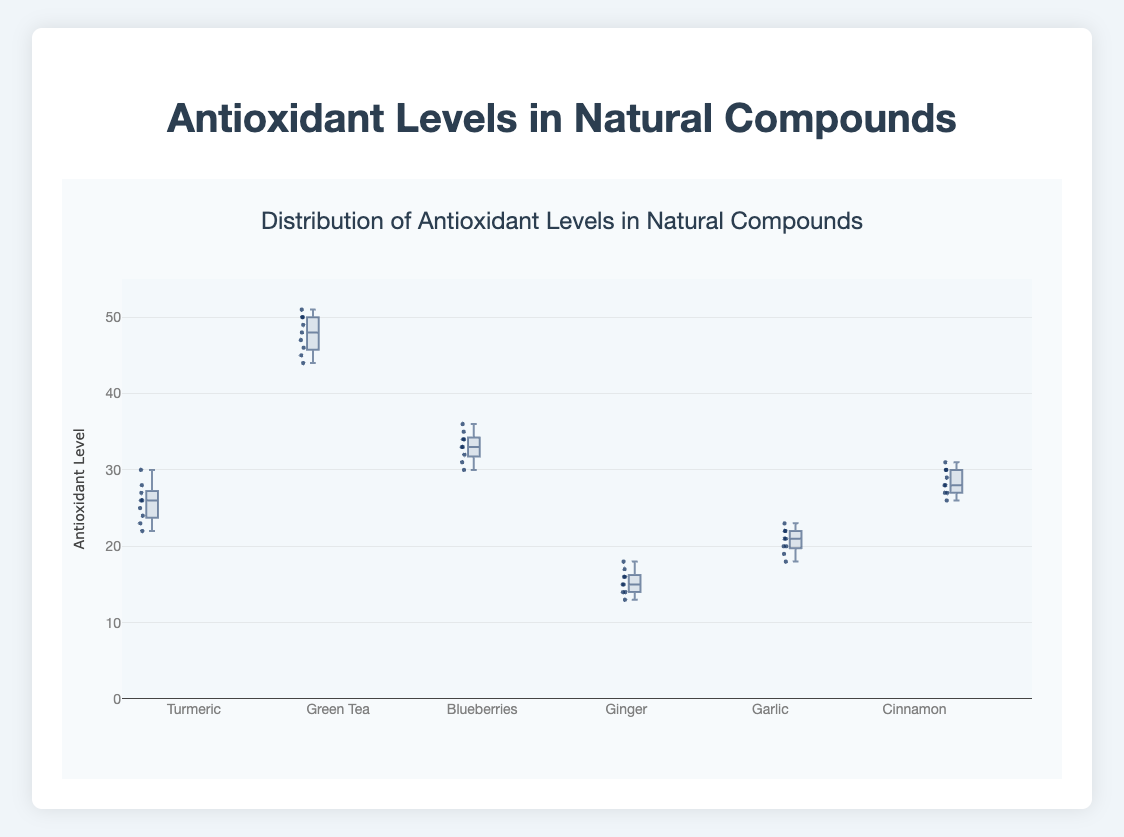What's the title of the plot? The title is clearly displayed at the top of the plot and it's meant to describe the content of the figure. The plot title provides a general overview of what the plot is showing.
Answer: Distribution of Antioxidant Levels in Natural Compounds What's the range of the y-axis? The range of the y-axis can be seen on the left side of the plot, and it defines the minimum and maximum values represented in the figure.
Answer: 0 to 55 Which compound has the highest median antioxidant level? To find the compound with the highest median antioxidant level, locate the central line in each boxplot that represents the median value for that compound.
Answer: Green Tea How many compounds are compared in the plot? The number of distinct box plots corresponds to the number of different compounds being compared. Count the different box plots along the x-axis.
Answer: 6 Which compound has the widest range of antioxidant levels? The range of antioxidant levels for each compound is represented by the distance between the bottom and top whiskers of the box plot. Identify the compound with the largest distance between these whiskers.
Answer: Green Tea What's the interquartile range (IQR) for Blueberries? The IQR is the range between the first quartile (Q1) and the third quartile (Q3) of the box plot. For Blueberries, locate the bottom and top edges of the box and measure the difference.
Answer: 4 Compare the median antioxidant levels of Turmeric and Ginger. Which one is higher and by how much? First, find the median line in each box plot for Turmeric and Ginger. Subtract the median of Ginger from the median of Turmeric to find the difference.
Answer: Turmeric is higher by 10 Which compound has the most variability (indicated by the length of the whiskers) in antioxidant levels, excluding outliers? By looking at the length of the whiskers on both ends of each boxplot, you can determine which compound shows the most spread in values, disregarding any individual points plotted outside the whiskers as outliers.
Answer: Green Tea Are there any compounds where the median antioxidant levels are the same? Which ones? Identify the median lines within the boxes for each compound. Compare them to see if any two or more compounds share the same median level.
Answer: Green Tea and Blueberries Does Garlic have any outliers? Outliers in a box plot are typically shown as individual points outside the whiskers. Look at Garlic's box plot to see if there are any individual points plotted separately.
Answer: No 